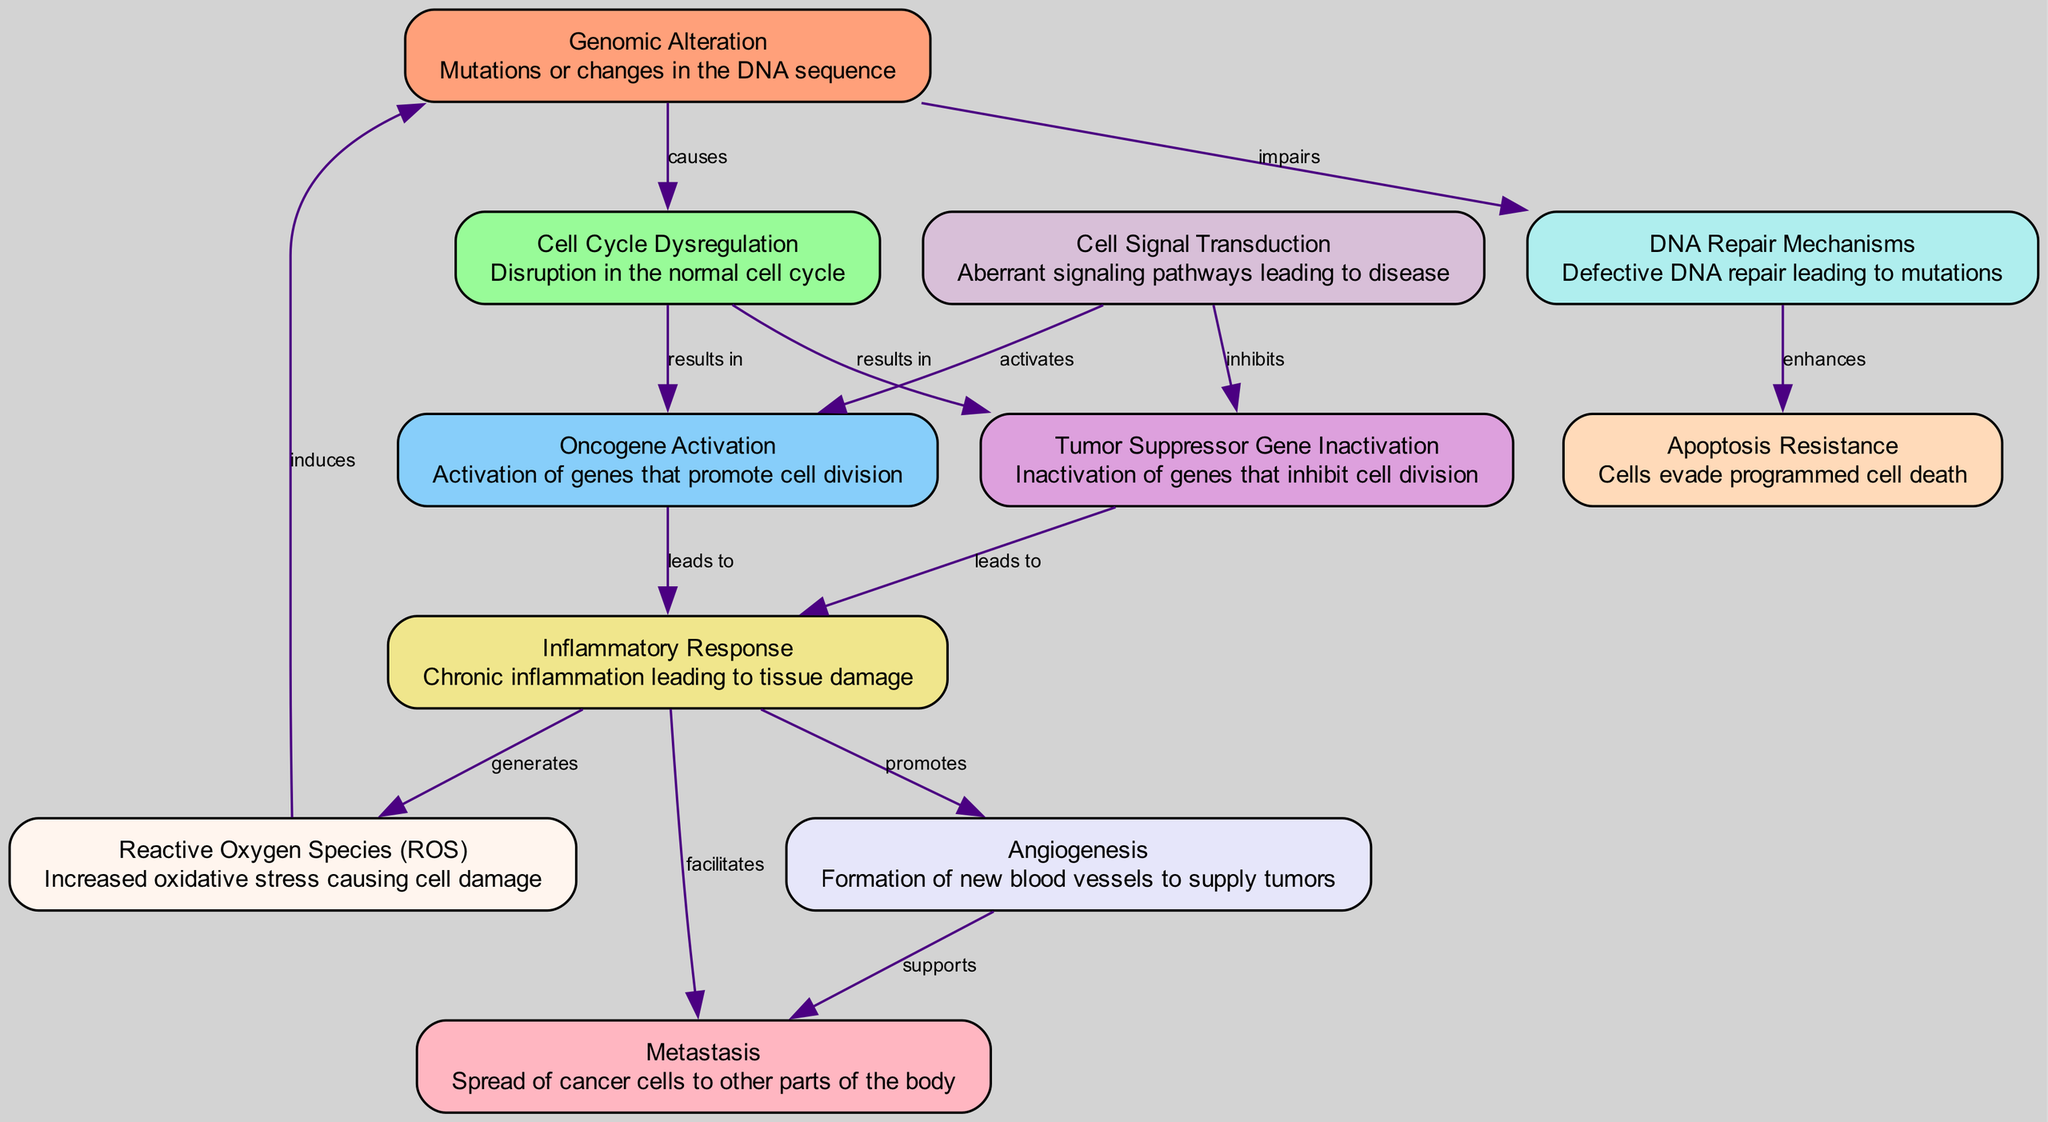What is the effect of genomic alteration on cell cycle dysregulation? According to the diagram, genomic alteration has a direct relationship with cell cycle dysregulation, as indicated by the edge that says "causes." This means that genomic alteration is a precursor or contributing factor to cell cycle dysregulation.
Answer: causes How many nodes are present in the diagram? To determine the number of nodes, we can count the entries in the nodes list provided. There are 11 distinct nodes representing key components related to disease progression.
Answer: 11 What leads to the activation of oncogenes? The diagram shows that cell cycle dysregulation results in the activation of oncogenes, as indicated by the edge labeled "results in." Thus, the disruption of the normal cell cycle is the initiating factor leading to oncogene activation.
Answer: cell cycle dysregulation Which process is promoted by the inflammatory response? The diagram indicates that the inflammatory response promotes angiogenesis, as shown by the labeled edge "promotes." This signifies that chronic inflammation contributes positively to the formation of new blood vessels.
Answer: angiogenesis What happens when DNA repair mechanisms are impaired? The diagram illustrates that if DNA repair mechanisms are impaired, it enhances apoptosis resistance, as indicated by the edge labeled "enhances." This means that defective repair can lead to an increased ability of cells to evade programmed cell death.
Answer: enhances How does increased oxidative stress influence genomic alterations? According to the diagram, reactive oxygen species (ROS) induce genomic alterations, as shown by the edge labeled "induces." This connection implies that the presence of ROS is a causative factor for changes in the DNA sequence.
Answer: induces What facilitates metastasis in the diagram? The diagram reveals that the inflammatory response facilitates metastasis, shown by the edge labeled "facilitates." This indicates that chronic inflammation can assist cancer cells in spreading to other parts of the body.
Answer: inflammatory response Which node directly results from oncogene activation? The directed relationships in the diagram indicate that oncogene activation leads to the inflammatory response as per the edge labelling "leads to." Therefore, the activation of oncogenes is directly associated with causing inflammation.
Answer: inflammatory response 